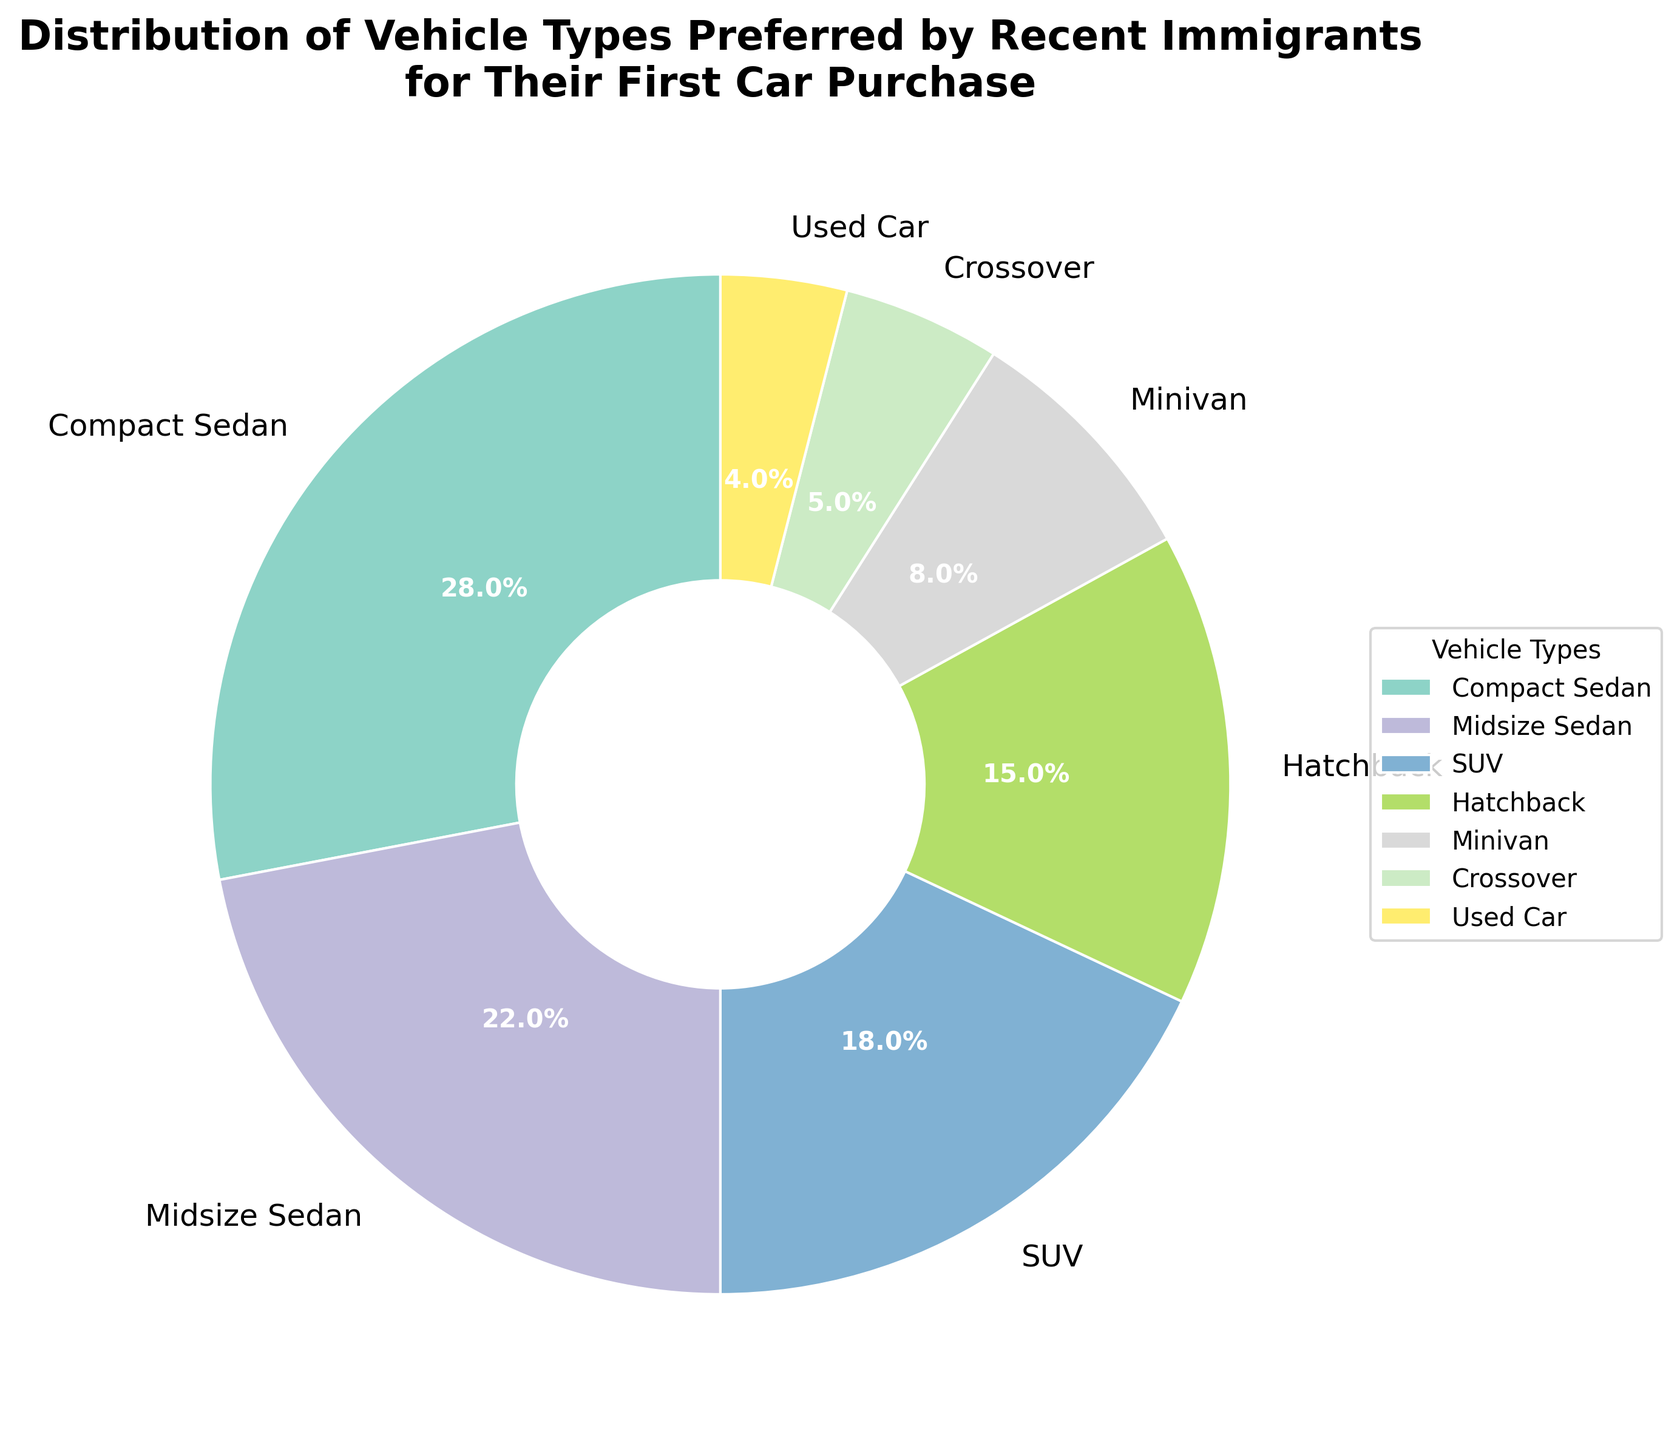What percentage of recent immigrants prefer SUVs for their first car purchase? Look at the section labeled "SUV" in the pie chart to find the percentage.
Answer: 18% Which vehicle type is preferred by the highest percentage of recent immigrants? Examine the pie chart to find the vehicle type with the largest wedge. It is labeled "Compact Sedan".
Answer: Compact Sedan How much higher is the preference percentage for Compact Sedans compared to Minivans? Note the percentages for Compact Sedans (28%) and Minivans (8%) in the pie chart. Subtract the Minivan percentage from the Compact Sedan percentage: 28% - 8% = 20%.
Answer: 20% Rank the vehicle types from most preferred to least preferred. By examining the wedge sizes and percentages on the chart: Compact Sedan (28%), Midsize Sedan (22%), SUV (18%), Hatchback (15%), Minivan (8%), Crossover (5%), Used Car (4%).
Answer: Compact Sedan, Midsize Sedan, SUV, Hatchback, Minivan, Crossover, Used Car What is the combined preference percentage for SUVs and Hatchbacks? Add the percentages for SUVs (18%) and Hatchbacks (15%) from the pie chart: 18% + 15% = 33%.
Answer: 33% Is the percentage of Compact Sedans preferred by recent immigrants more than double that of Minivans? The percentage for Compact Sedans is 28%, and for Minivans, it is 8%. Double of 8% is 16%, and 28% is indeed more than 16%.
Answer: Yes Which vehicle type is preferred less than 10% by recent immigrants? Examine the pie chart for vehicle types with less than a 10% share. Minivan (8%), Crossover (5%), and Used Car (4%) meet this criterion.
Answer: Minivan, Crossover, Used Car Which color corresponds to the SUV wedge in the pie chart? Identify the wedge labeled "SUV" and describe its color.
Answer: Depends on the exact visualization, but typically it's a specific color from the Set3 colormap, which varies. (Provide the specific color name if possible) What's the difference in preference percentage between Midsize Sedans and Crossovers? Note the percentages for Midsize Sedans (22%) and Crossovers (5%) in the pie chart. Subtract the Crossover percentage from the Midsize Sedan percentage: 22% - 5% = 17%.
Answer: 17% Do more recent immigrants prefer used cars or crossovers? Compare the wedges for used cars and crossovers on the pie chart. The used car wedge is labeled with a percentage of 4%, and the crossover wedge is labeled with a percentage of 5%.
Answer: Crossovers 